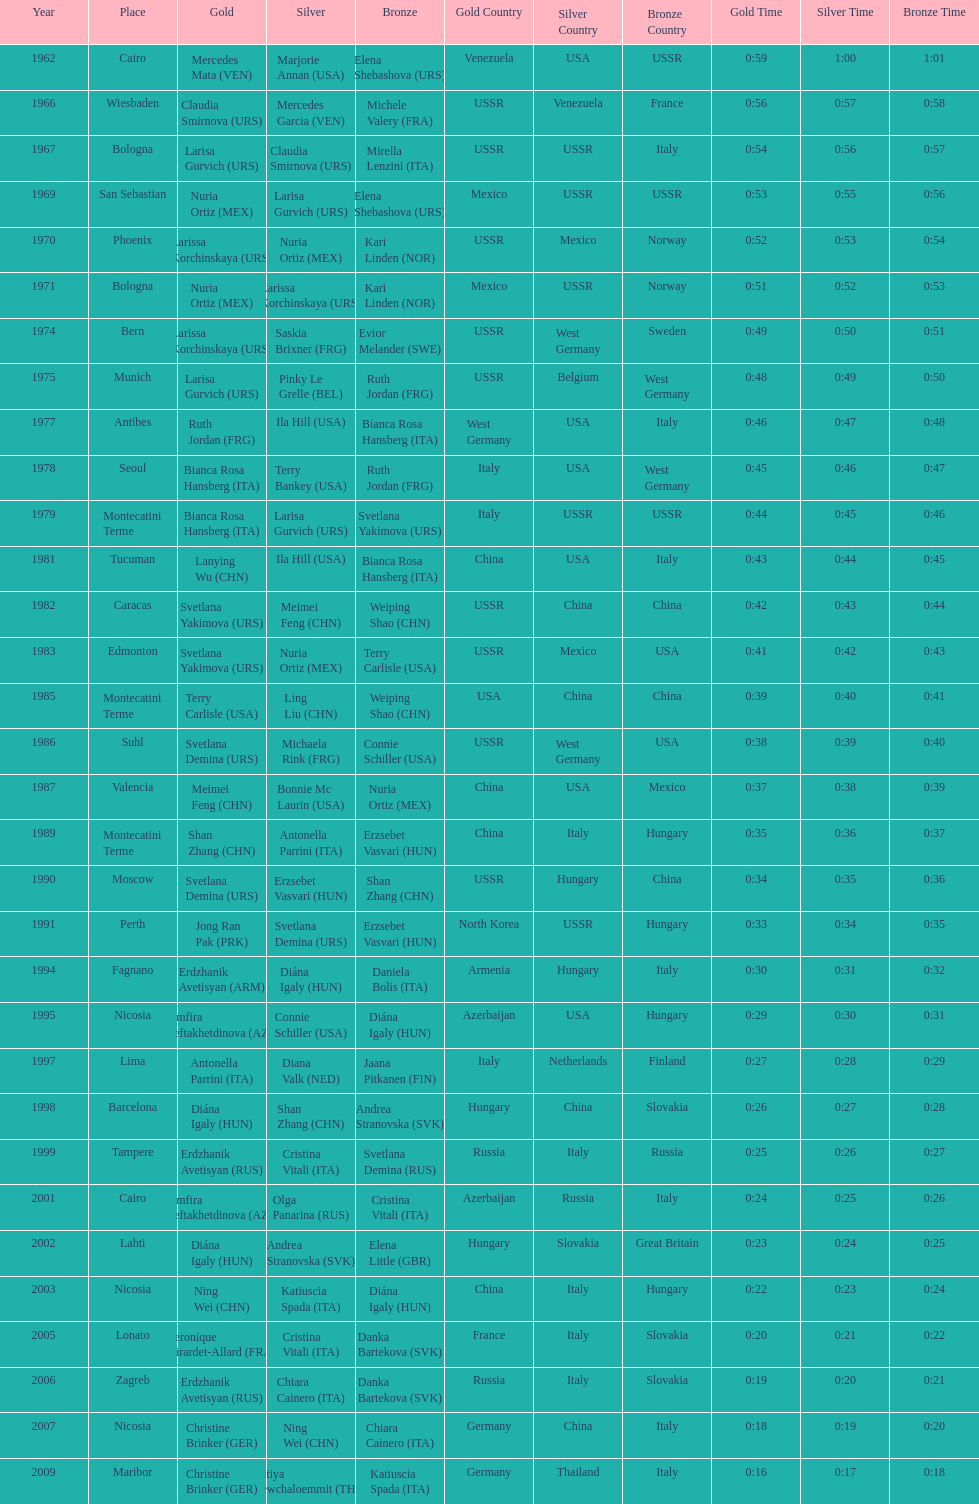Who won the only gold medal in 1962? Mercedes Mata. 